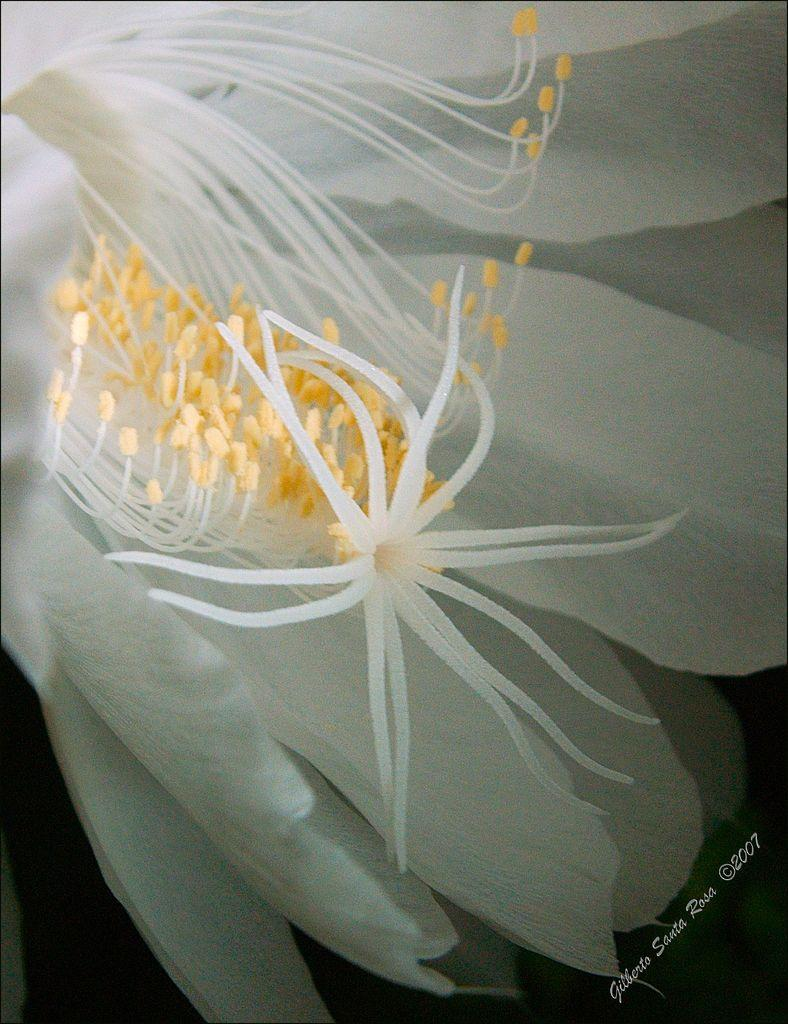What is the main subject of the image? There is a flower in the image. What is the name of the nation that is printed on the flower in the image? There is no nation or print present on the flower in the image. The flower is a natural object and does not have any text or symbols associated with it. 